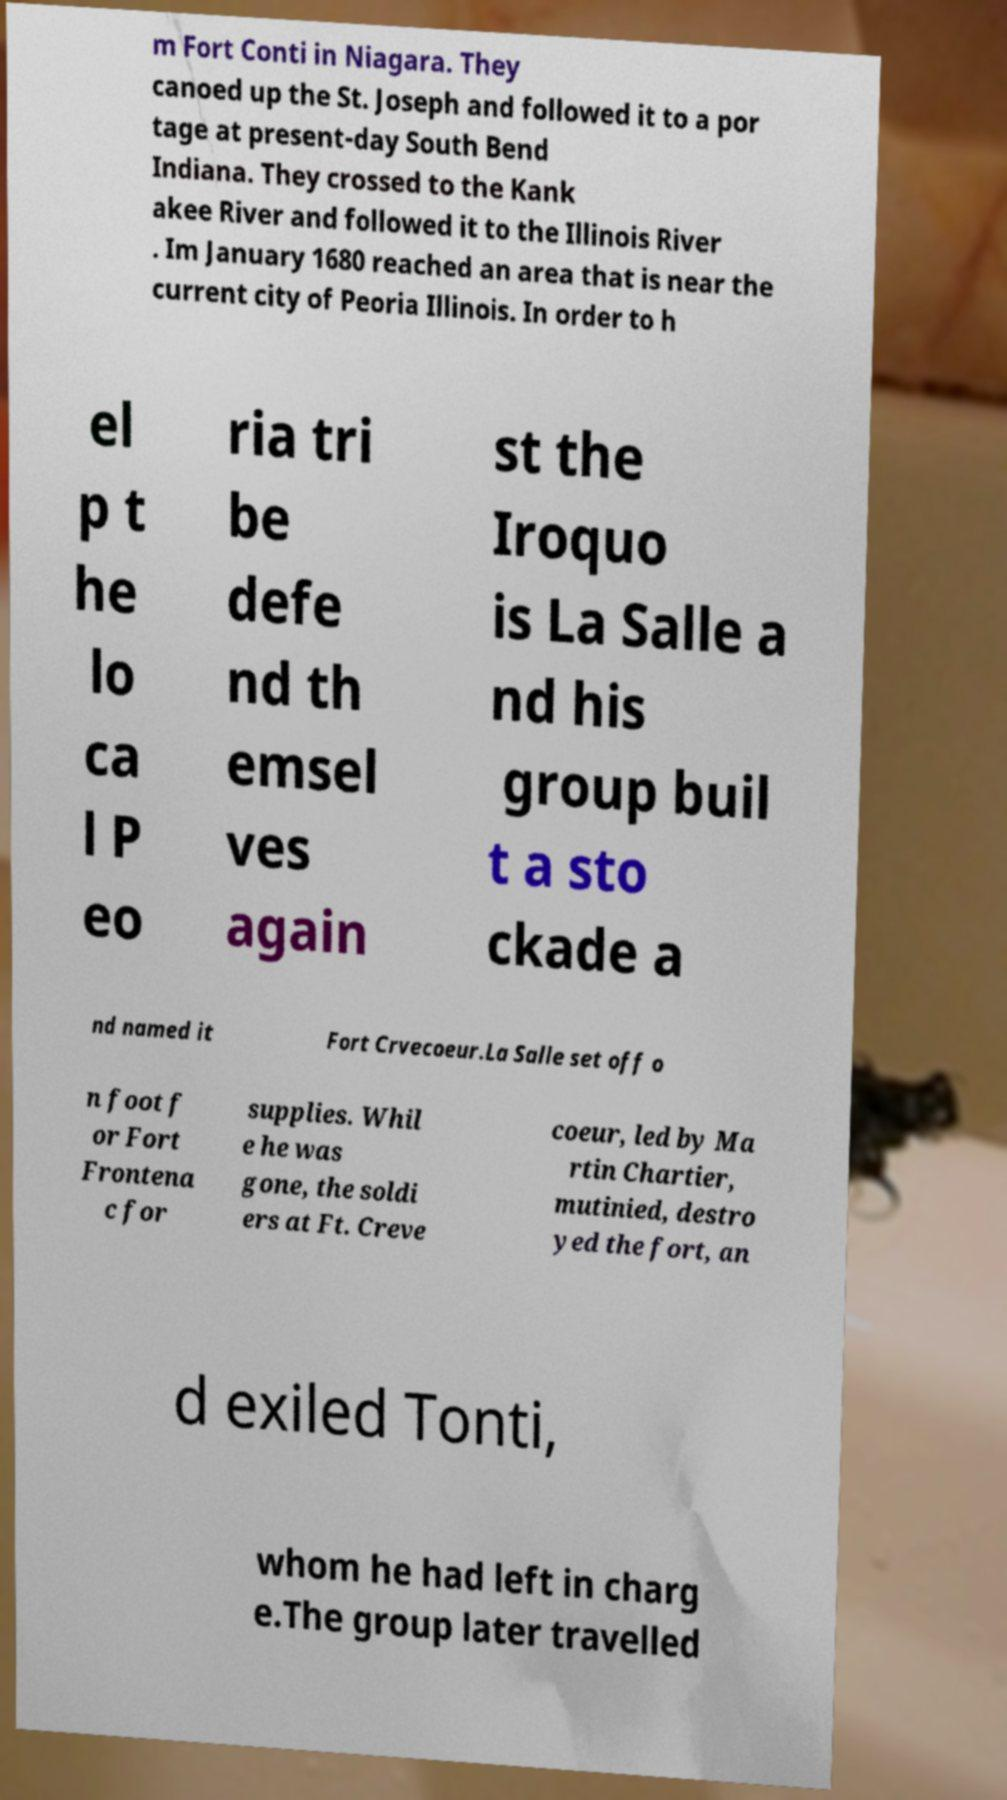Could you assist in decoding the text presented in this image and type it out clearly? m Fort Conti in Niagara. They canoed up the St. Joseph and followed it to a por tage at present-day South Bend Indiana. They crossed to the Kank akee River and followed it to the Illinois River . Im January 1680 reached an area that is near the current city of Peoria Illinois. In order to h el p t he lo ca l P eo ria tri be defe nd th emsel ves again st the Iroquo is La Salle a nd his group buil t a sto ckade a nd named it Fort Crvecoeur.La Salle set off o n foot f or Fort Frontena c for supplies. Whil e he was gone, the soldi ers at Ft. Creve coeur, led by Ma rtin Chartier, mutinied, destro yed the fort, an d exiled Tonti, whom he had left in charg e.The group later travelled 